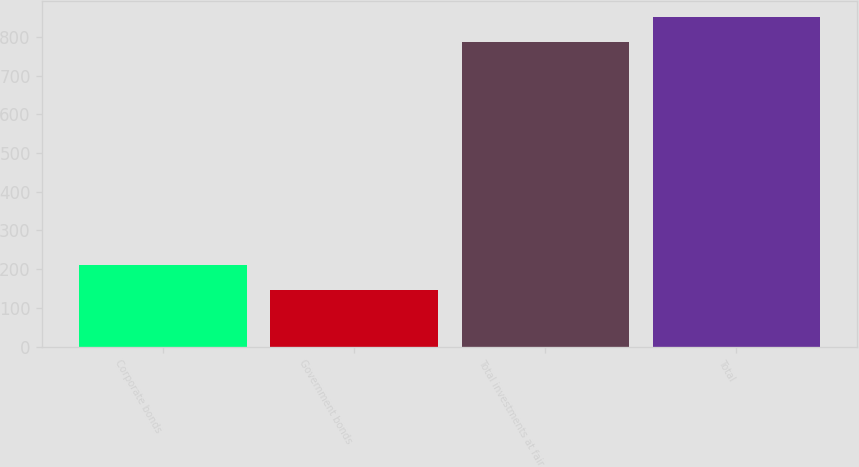<chart> <loc_0><loc_0><loc_500><loc_500><bar_chart><fcel>Corporate bonds<fcel>Government bonds<fcel>Total investments at fair<fcel>Total<nl><fcel>209.77<fcel>145.6<fcel>787.3<fcel>851.47<nl></chart> 